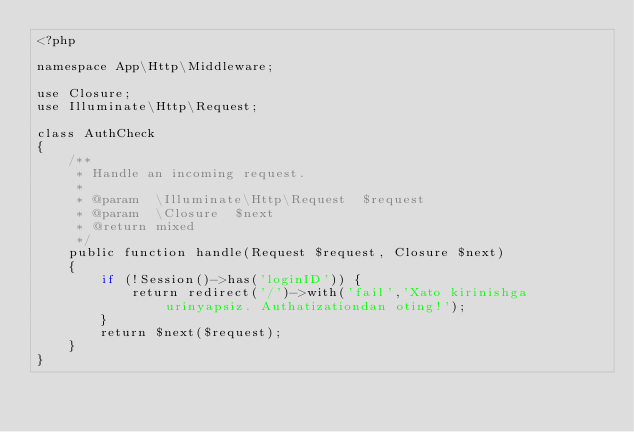Convert code to text. <code><loc_0><loc_0><loc_500><loc_500><_PHP_><?php

namespace App\Http\Middleware;

use Closure;
use Illuminate\Http\Request;

class AuthCheck
{
    /**
     * Handle an incoming request.
     *
     * @param  \Illuminate\Http\Request  $request
     * @param  \Closure  $next
     * @return mixed
     */
    public function handle(Request $request, Closure $next)
    {
        if (!Session()->has('loginID')) {
            return redirect('/')->with('fail','Xato kirinishga urinyapsiz. Authatizationdan oting!');
        }
        return $next($request);
    }
}
</code> 